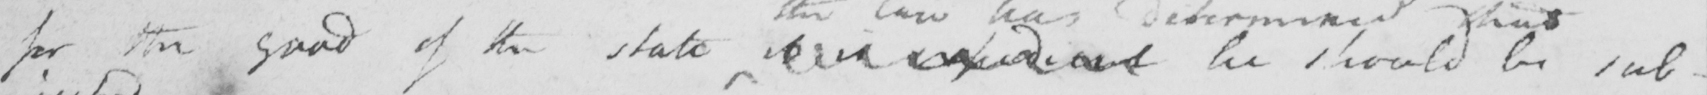What does this handwritten line say? for the good of the state it is expedient he should be sub- 